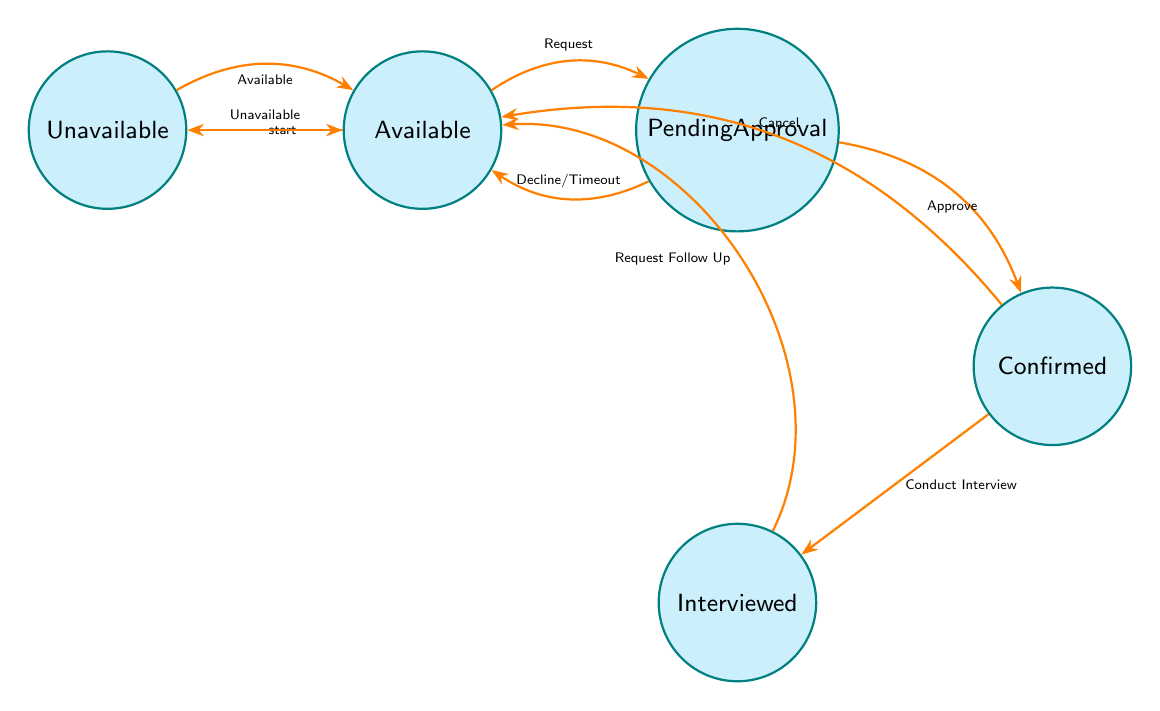What is the initial state of the expert availability status? The diagram indicates the initial state is "Available," as denoted by the arrow pointing from nowhere to the "Available" node.
Answer: Available How many nodes are present in the diagram? Counting the nodes, we see five states: Available, Pending Approval, Confirmed, Interviewed, and Unavailable. Therefore, the total number of nodes is 5.
Answer: 5 What is the target state when an interview request is sent? The transition from the "Available" state to "PendingApproval" indicates that when an interview request is sent, the target state is "PendingApproval."
Answer: PendingApproval Which state follows after an interview is conducted? The transition from "Confirmed" to "Interviewed" shows that after conducting the interview, the next state is "Interviewed."
Answer: Interviewed What happens if the expert declines the interview request? The transition from "PendingApproval" to "Available" indicates that if the request is declined, the state will revert back to "Available."
Answer: Available If the expert is marked as "Unavailable," what triggers the transition back to "Available"? The "Available" trigger from the "Unavailable" state signifies that the expert can return to the "Available" state if they become available again.
Answer: Available How many transitions lead from the "PendingApproval" state? The "PendingApproval" state has three transitions: Approve, Decline, and Timeout, implying there are three possible actions from this state.
Answer: 3 What state precedes "Interviewed"? The transition to the "Interviewed" state follows the "Confirmed" state, thus indicating "Confirmed" is the preceding state.
Answer: Confirmed Which trigger will move the status from "Interviewed" back to "Available"? The transition labeled "RequestFollowUp" from the "Interviewed" state indicates that this trigger will move the status back to "Available."
Answer: RequestFollowUp 